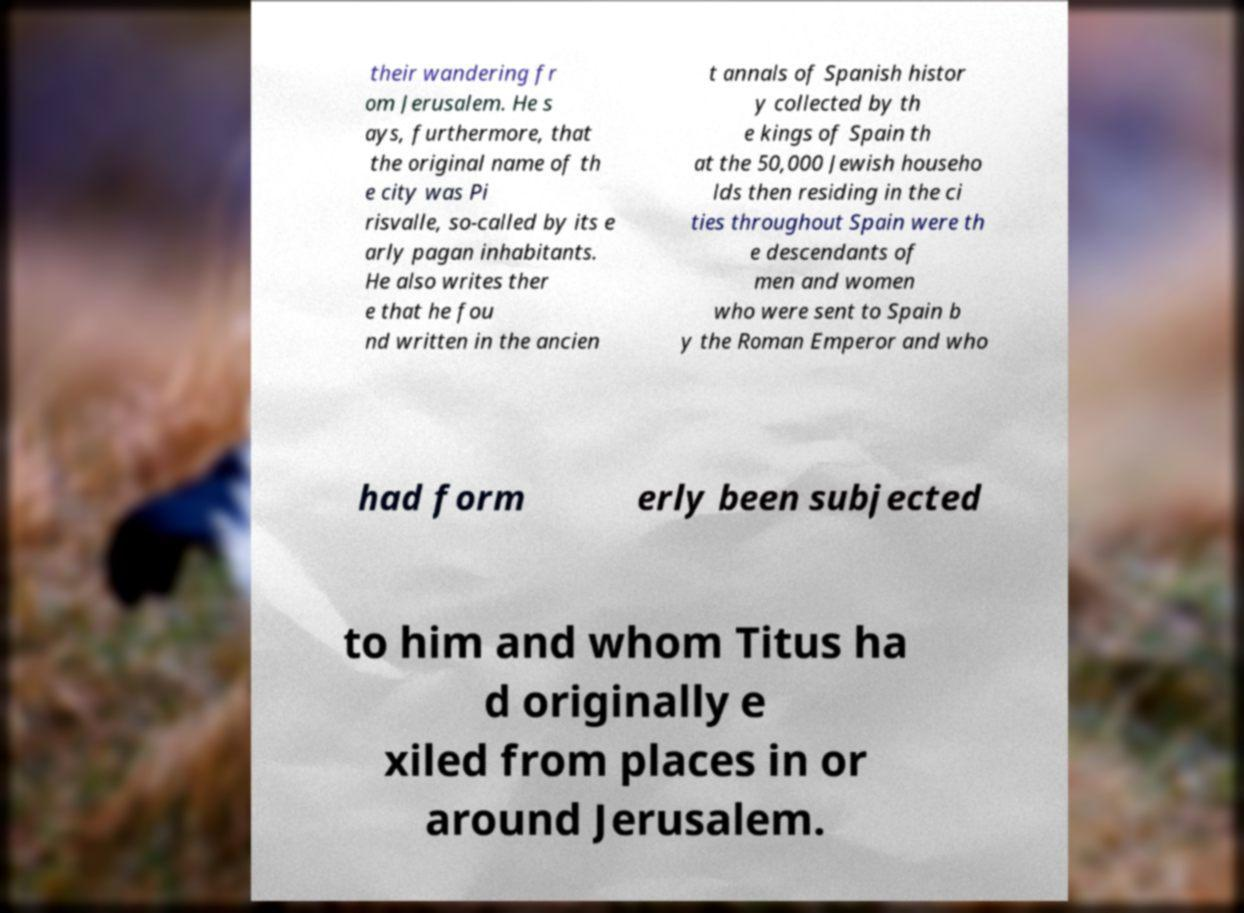Can you accurately transcribe the text from the provided image for me? their wandering fr om Jerusalem. He s ays, furthermore, that the original name of th e city was Pi risvalle, so-called by its e arly pagan inhabitants. He also writes ther e that he fou nd written in the ancien t annals of Spanish histor y collected by th e kings of Spain th at the 50,000 Jewish househo lds then residing in the ci ties throughout Spain were th e descendants of men and women who were sent to Spain b y the Roman Emperor and who had form erly been subjected to him and whom Titus ha d originally e xiled from places in or around Jerusalem. 